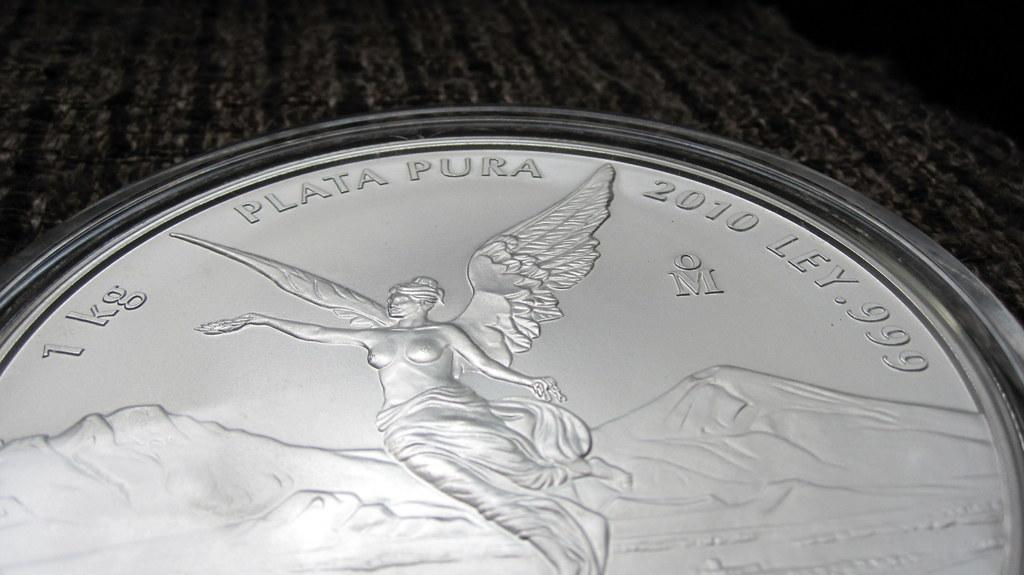<image>
Offer a succinct explanation of the picture presented. A coin dated 2010 has an angel on it. 